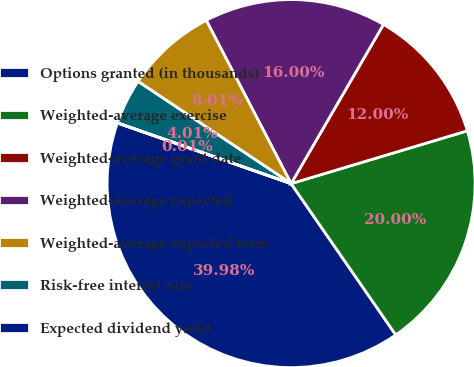Convert chart. <chart><loc_0><loc_0><loc_500><loc_500><pie_chart><fcel>Options granted (in thousands)<fcel>Weighted-average exercise<fcel>Weighted-average grant date<fcel>Weighted-average expected<fcel>Weighted-average expected term<fcel>Risk-free interest rate<fcel>Expected dividend yield<nl><fcel>39.98%<fcel>20.0%<fcel>12.0%<fcel>16.0%<fcel>8.01%<fcel>4.01%<fcel>0.01%<nl></chart> 